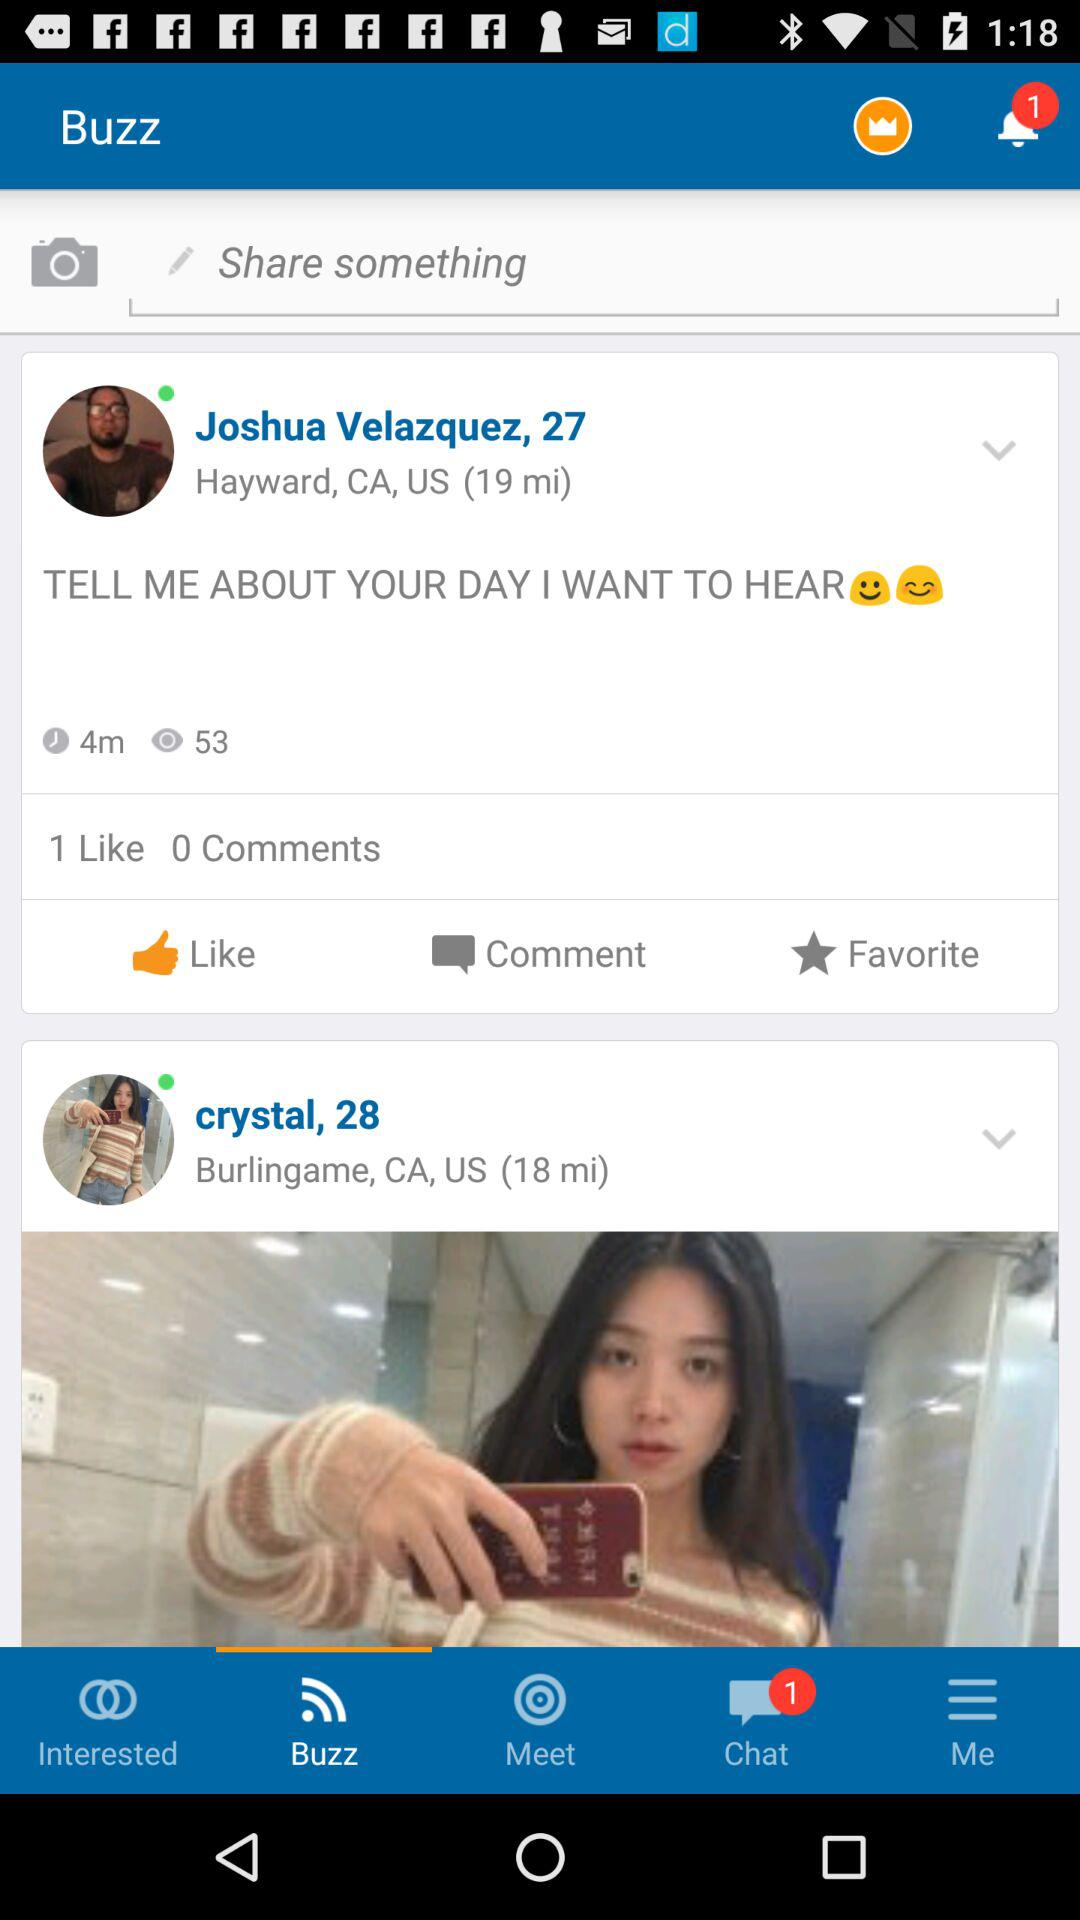What is the location of Joshua Velazquez? The location is Hayward, CA, US. 